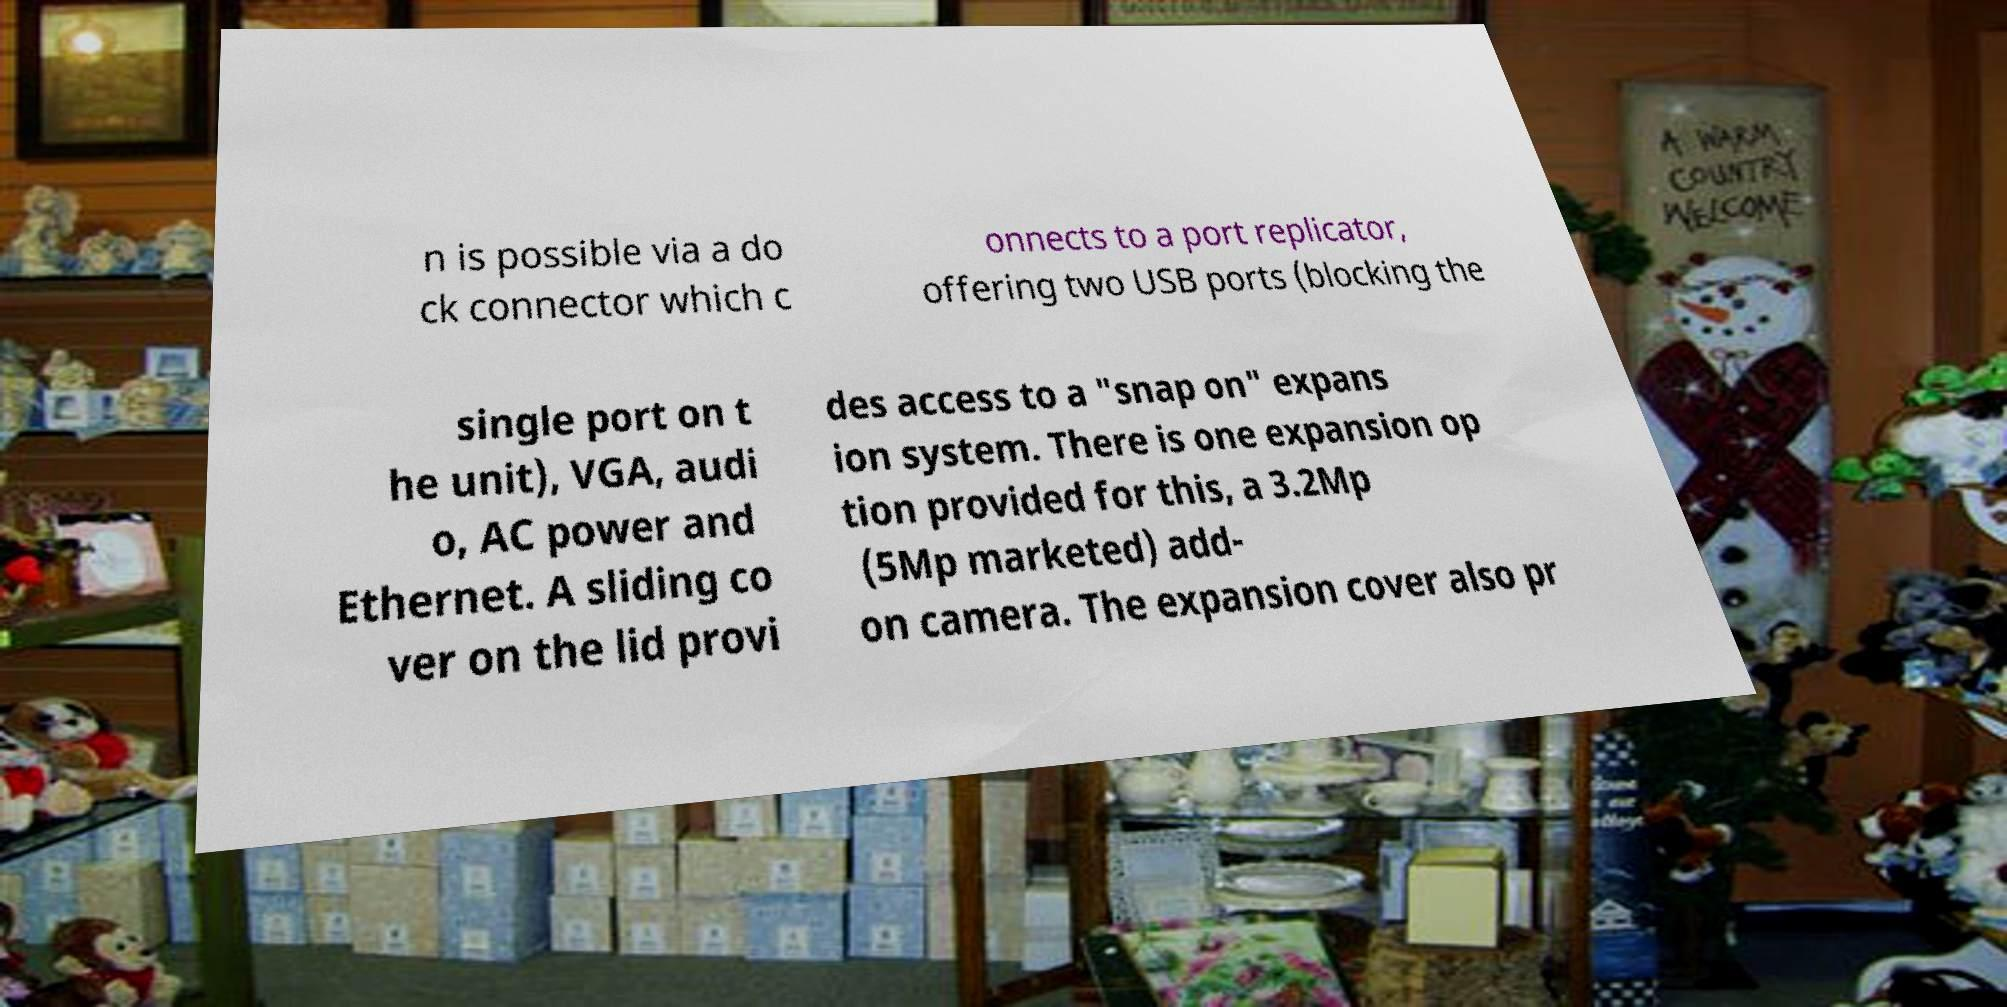Could you assist in decoding the text presented in this image and type it out clearly? n is possible via a do ck connector which c onnects to a port replicator, offering two USB ports (blocking the single port on t he unit), VGA, audi o, AC power and Ethernet. A sliding co ver on the lid provi des access to a "snap on" expans ion system. There is one expansion op tion provided for this, a 3.2Mp (5Mp marketed) add- on camera. The expansion cover also pr 